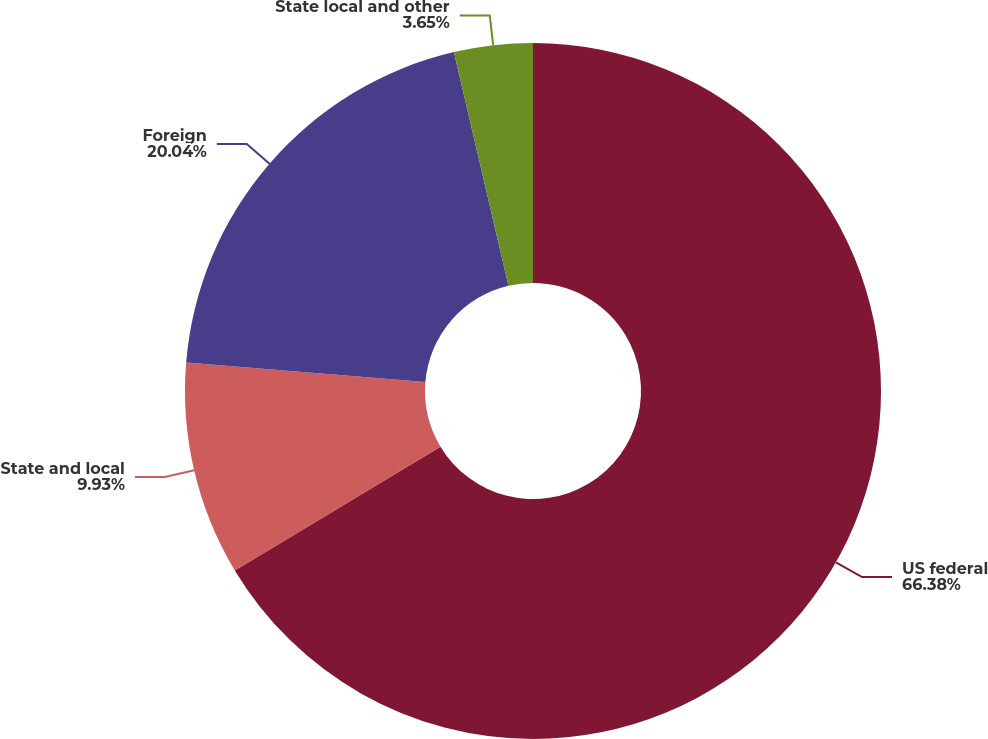Convert chart to OTSL. <chart><loc_0><loc_0><loc_500><loc_500><pie_chart><fcel>US federal<fcel>State and local<fcel>Foreign<fcel>State local and other<nl><fcel>66.38%<fcel>9.93%<fcel>20.04%<fcel>3.65%<nl></chart> 